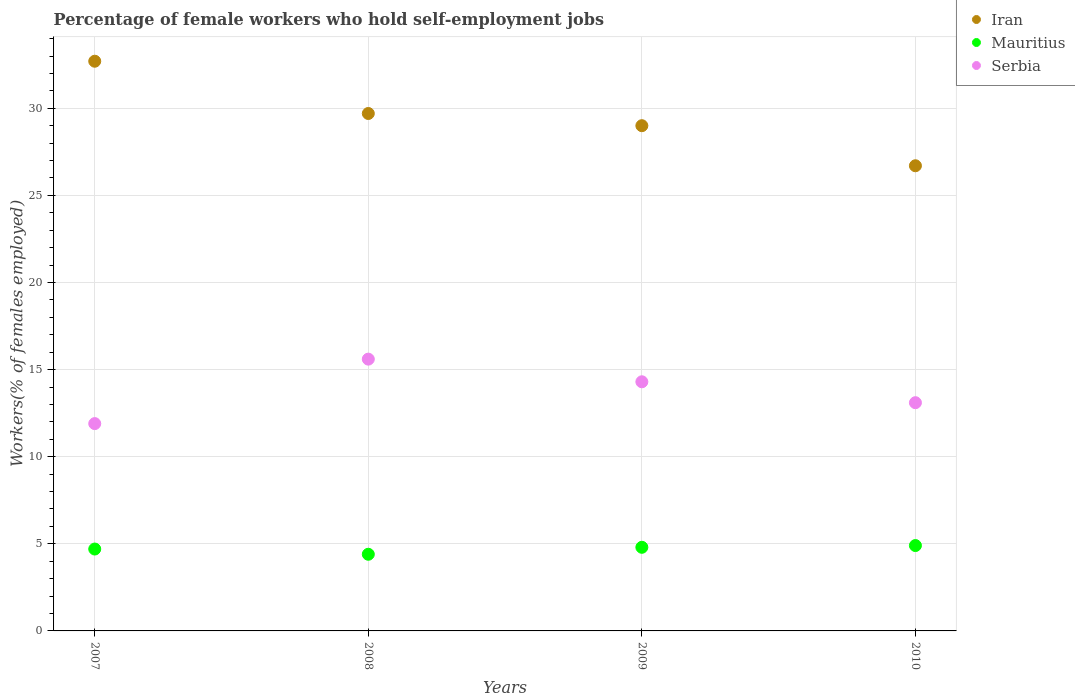How many different coloured dotlines are there?
Keep it short and to the point. 3. Is the number of dotlines equal to the number of legend labels?
Offer a terse response. Yes. What is the percentage of self-employed female workers in Iran in 2007?
Your answer should be compact. 32.7. Across all years, what is the maximum percentage of self-employed female workers in Mauritius?
Your response must be concise. 4.9. Across all years, what is the minimum percentage of self-employed female workers in Serbia?
Make the answer very short. 11.9. In which year was the percentage of self-employed female workers in Mauritius maximum?
Give a very brief answer. 2010. What is the total percentage of self-employed female workers in Mauritius in the graph?
Give a very brief answer. 18.8. What is the difference between the percentage of self-employed female workers in Mauritius in 2007 and that in 2009?
Provide a short and direct response. -0.1. What is the difference between the percentage of self-employed female workers in Mauritius in 2009 and the percentage of self-employed female workers in Iran in 2010?
Your response must be concise. -21.9. What is the average percentage of self-employed female workers in Serbia per year?
Keep it short and to the point. 13.73. In the year 2007, what is the difference between the percentage of self-employed female workers in Serbia and percentage of self-employed female workers in Mauritius?
Your response must be concise. 7.2. In how many years, is the percentage of self-employed female workers in Serbia greater than 3 %?
Ensure brevity in your answer.  4. What is the ratio of the percentage of self-employed female workers in Iran in 2007 to that in 2008?
Ensure brevity in your answer.  1.1. What is the difference between the highest and the second highest percentage of self-employed female workers in Serbia?
Provide a succinct answer. 1.3. Is the sum of the percentage of self-employed female workers in Iran in 2007 and 2009 greater than the maximum percentage of self-employed female workers in Serbia across all years?
Keep it short and to the point. Yes. Is the percentage of self-employed female workers in Serbia strictly greater than the percentage of self-employed female workers in Iran over the years?
Give a very brief answer. No. Is the percentage of self-employed female workers in Serbia strictly less than the percentage of self-employed female workers in Mauritius over the years?
Keep it short and to the point. No. Are the values on the major ticks of Y-axis written in scientific E-notation?
Give a very brief answer. No. What is the title of the graph?
Offer a very short reply. Percentage of female workers who hold self-employment jobs. What is the label or title of the X-axis?
Make the answer very short. Years. What is the label or title of the Y-axis?
Give a very brief answer. Workers(% of females employed). What is the Workers(% of females employed) of Iran in 2007?
Your answer should be compact. 32.7. What is the Workers(% of females employed) of Mauritius in 2007?
Ensure brevity in your answer.  4.7. What is the Workers(% of females employed) of Serbia in 2007?
Your answer should be compact. 11.9. What is the Workers(% of females employed) of Iran in 2008?
Offer a very short reply. 29.7. What is the Workers(% of females employed) of Mauritius in 2008?
Your response must be concise. 4.4. What is the Workers(% of females employed) in Serbia in 2008?
Provide a short and direct response. 15.6. What is the Workers(% of females employed) of Mauritius in 2009?
Offer a terse response. 4.8. What is the Workers(% of females employed) of Serbia in 2009?
Give a very brief answer. 14.3. What is the Workers(% of females employed) in Iran in 2010?
Your answer should be compact. 26.7. What is the Workers(% of females employed) of Mauritius in 2010?
Your response must be concise. 4.9. What is the Workers(% of females employed) in Serbia in 2010?
Offer a very short reply. 13.1. Across all years, what is the maximum Workers(% of females employed) in Iran?
Your answer should be very brief. 32.7. Across all years, what is the maximum Workers(% of females employed) of Mauritius?
Your answer should be very brief. 4.9. Across all years, what is the maximum Workers(% of females employed) in Serbia?
Your answer should be compact. 15.6. Across all years, what is the minimum Workers(% of females employed) in Iran?
Keep it short and to the point. 26.7. Across all years, what is the minimum Workers(% of females employed) of Mauritius?
Your answer should be compact. 4.4. Across all years, what is the minimum Workers(% of females employed) of Serbia?
Make the answer very short. 11.9. What is the total Workers(% of females employed) of Iran in the graph?
Your answer should be very brief. 118.1. What is the total Workers(% of females employed) in Serbia in the graph?
Provide a succinct answer. 54.9. What is the difference between the Workers(% of females employed) of Mauritius in 2007 and that in 2008?
Offer a terse response. 0.3. What is the difference between the Workers(% of females employed) in Mauritius in 2007 and that in 2009?
Offer a very short reply. -0.1. What is the difference between the Workers(% of females employed) of Iran in 2007 and that in 2010?
Give a very brief answer. 6. What is the difference between the Workers(% of females employed) of Mauritius in 2007 and that in 2010?
Provide a short and direct response. -0.2. What is the difference between the Workers(% of females employed) of Serbia in 2007 and that in 2010?
Your response must be concise. -1.2. What is the difference between the Workers(% of females employed) of Iran in 2008 and that in 2009?
Your answer should be compact. 0.7. What is the difference between the Workers(% of females employed) of Serbia in 2008 and that in 2009?
Your response must be concise. 1.3. What is the difference between the Workers(% of females employed) of Serbia in 2009 and that in 2010?
Your answer should be compact. 1.2. What is the difference between the Workers(% of females employed) in Iran in 2007 and the Workers(% of females employed) in Mauritius in 2008?
Keep it short and to the point. 28.3. What is the difference between the Workers(% of females employed) in Mauritius in 2007 and the Workers(% of females employed) in Serbia in 2008?
Ensure brevity in your answer.  -10.9. What is the difference between the Workers(% of females employed) of Iran in 2007 and the Workers(% of females employed) of Mauritius in 2009?
Give a very brief answer. 27.9. What is the difference between the Workers(% of females employed) of Iran in 2007 and the Workers(% of females employed) of Serbia in 2009?
Provide a short and direct response. 18.4. What is the difference between the Workers(% of females employed) in Mauritius in 2007 and the Workers(% of females employed) in Serbia in 2009?
Offer a terse response. -9.6. What is the difference between the Workers(% of females employed) of Iran in 2007 and the Workers(% of females employed) of Mauritius in 2010?
Ensure brevity in your answer.  27.8. What is the difference between the Workers(% of females employed) of Iran in 2007 and the Workers(% of females employed) of Serbia in 2010?
Offer a terse response. 19.6. What is the difference between the Workers(% of females employed) in Iran in 2008 and the Workers(% of females employed) in Mauritius in 2009?
Give a very brief answer. 24.9. What is the difference between the Workers(% of females employed) in Mauritius in 2008 and the Workers(% of females employed) in Serbia in 2009?
Your answer should be compact. -9.9. What is the difference between the Workers(% of females employed) of Iran in 2008 and the Workers(% of females employed) of Mauritius in 2010?
Offer a very short reply. 24.8. What is the difference between the Workers(% of females employed) of Mauritius in 2008 and the Workers(% of females employed) of Serbia in 2010?
Offer a terse response. -8.7. What is the difference between the Workers(% of females employed) of Iran in 2009 and the Workers(% of females employed) of Mauritius in 2010?
Give a very brief answer. 24.1. What is the difference between the Workers(% of females employed) in Iran in 2009 and the Workers(% of females employed) in Serbia in 2010?
Make the answer very short. 15.9. What is the difference between the Workers(% of females employed) of Mauritius in 2009 and the Workers(% of females employed) of Serbia in 2010?
Make the answer very short. -8.3. What is the average Workers(% of females employed) in Iran per year?
Give a very brief answer. 29.52. What is the average Workers(% of females employed) in Mauritius per year?
Provide a succinct answer. 4.7. What is the average Workers(% of females employed) in Serbia per year?
Your response must be concise. 13.72. In the year 2007, what is the difference between the Workers(% of females employed) of Iran and Workers(% of females employed) of Serbia?
Give a very brief answer. 20.8. In the year 2008, what is the difference between the Workers(% of females employed) of Iran and Workers(% of females employed) of Mauritius?
Give a very brief answer. 25.3. In the year 2009, what is the difference between the Workers(% of females employed) of Iran and Workers(% of females employed) of Mauritius?
Make the answer very short. 24.2. In the year 2009, what is the difference between the Workers(% of females employed) in Iran and Workers(% of females employed) in Serbia?
Your answer should be compact. 14.7. In the year 2010, what is the difference between the Workers(% of females employed) of Iran and Workers(% of females employed) of Mauritius?
Your response must be concise. 21.8. In the year 2010, what is the difference between the Workers(% of females employed) of Mauritius and Workers(% of females employed) of Serbia?
Your response must be concise. -8.2. What is the ratio of the Workers(% of females employed) in Iran in 2007 to that in 2008?
Make the answer very short. 1.1. What is the ratio of the Workers(% of females employed) of Mauritius in 2007 to that in 2008?
Keep it short and to the point. 1.07. What is the ratio of the Workers(% of females employed) of Serbia in 2007 to that in 2008?
Keep it short and to the point. 0.76. What is the ratio of the Workers(% of females employed) in Iran in 2007 to that in 2009?
Keep it short and to the point. 1.13. What is the ratio of the Workers(% of females employed) in Mauritius in 2007 to that in 2009?
Your answer should be very brief. 0.98. What is the ratio of the Workers(% of females employed) of Serbia in 2007 to that in 2009?
Make the answer very short. 0.83. What is the ratio of the Workers(% of females employed) in Iran in 2007 to that in 2010?
Your answer should be compact. 1.22. What is the ratio of the Workers(% of females employed) in Mauritius in 2007 to that in 2010?
Provide a short and direct response. 0.96. What is the ratio of the Workers(% of females employed) of Serbia in 2007 to that in 2010?
Provide a succinct answer. 0.91. What is the ratio of the Workers(% of females employed) in Iran in 2008 to that in 2009?
Ensure brevity in your answer.  1.02. What is the ratio of the Workers(% of females employed) of Iran in 2008 to that in 2010?
Ensure brevity in your answer.  1.11. What is the ratio of the Workers(% of females employed) of Mauritius in 2008 to that in 2010?
Offer a terse response. 0.9. What is the ratio of the Workers(% of females employed) of Serbia in 2008 to that in 2010?
Provide a short and direct response. 1.19. What is the ratio of the Workers(% of females employed) of Iran in 2009 to that in 2010?
Keep it short and to the point. 1.09. What is the ratio of the Workers(% of females employed) in Mauritius in 2009 to that in 2010?
Offer a terse response. 0.98. What is the ratio of the Workers(% of females employed) in Serbia in 2009 to that in 2010?
Provide a succinct answer. 1.09. What is the difference between the highest and the second highest Workers(% of females employed) of Iran?
Your answer should be very brief. 3. What is the difference between the highest and the second highest Workers(% of females employed) of Mauritius?
Offer a terse response. 0.1. What is the difference between the highest and the lowest Workers(% of females employed) in Mauritius?
Give a very brief answer. 0.5. What is the difference between the highest and the lowest Workers(% of females employed) of Serbia?
Offer a terse response. 3.7. 